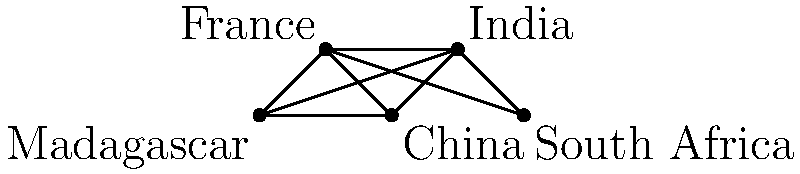Based on the diplomatic network graph shown, which country acts as the most crucial intermediary for Madagascar's international relations, as measured by its betweenness centrality? To determine the country with the highest betweenness centrality, we need to follow these steps:

1. Identify all shortest paths between pairs of countries.
2. Count how many of these paths pass through each country.
3. Calculate the betweenness centrality for each country.

Let's analyze each country:

Madagascar (M):
- No shortest paths pass through Madagascar as it's an endpoint.
Betweenness centrality = 0

France (F):
- Shortest path for M-SA passes through F
- Shortest path for C-SA passes through F
- Shortest path for C-I can pass through F
Betweenness centrality = 2.5

China (C):
- No shortest paths pass through China
Betweenness centrality = 0

India (I):
- Shortest path for M-SA can pass through I
Betweenness centrality = 0.5

South Africa (SA):
- No shortest paths pass through South Africa
Betweenness centrality = 0

France has the highest betweenness centrality, making it the most crucial intermediary in this diplomatic network.
Answer: France 